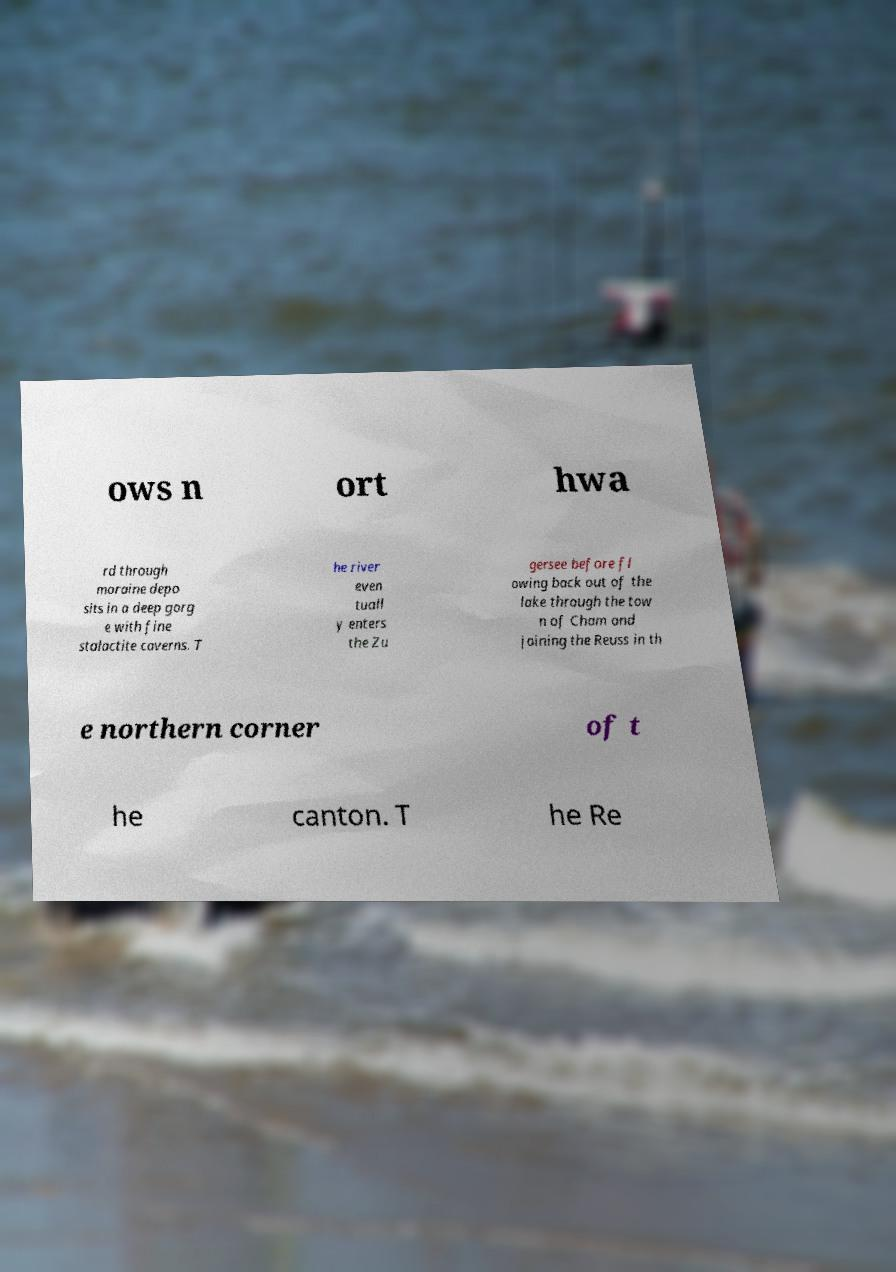There's text embedded in this image that I need extracted. Can you transcribe it verbatim? ows n ort hwa rd through moraine depo sits in a deep gorg e with fine stalactite caverns. T he river even tuall y enters the Zu gersee before fl owing back out of the lake through the tow n of Cham and joining the Reuss in th e northern corner of t he canton. T he Re 